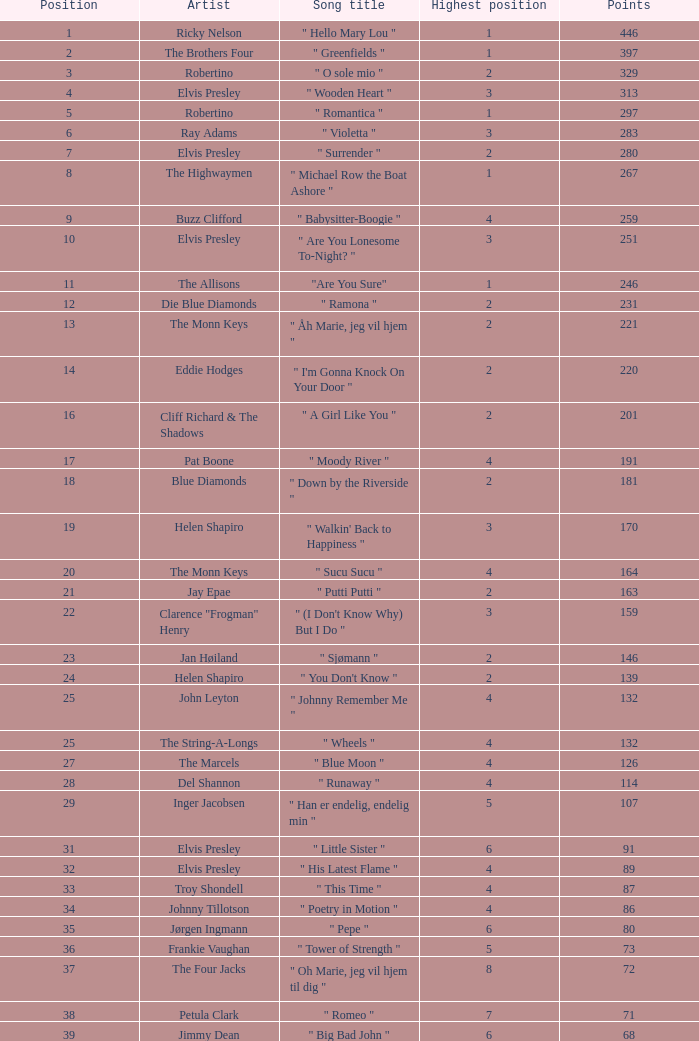What's the name of the song that garnered 259 points? " Babysitter-Boogie ". 